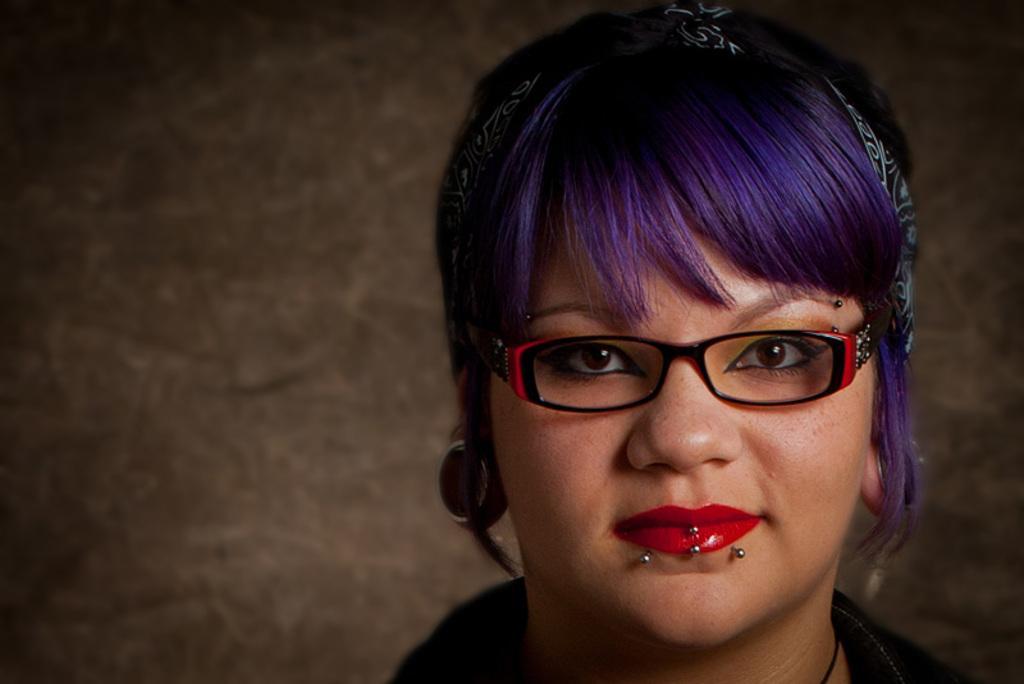Please provide a concise description of this image. In the picture we can see a head part of a woman with a red lipstick and purple hair and in the background we can see a wall. 